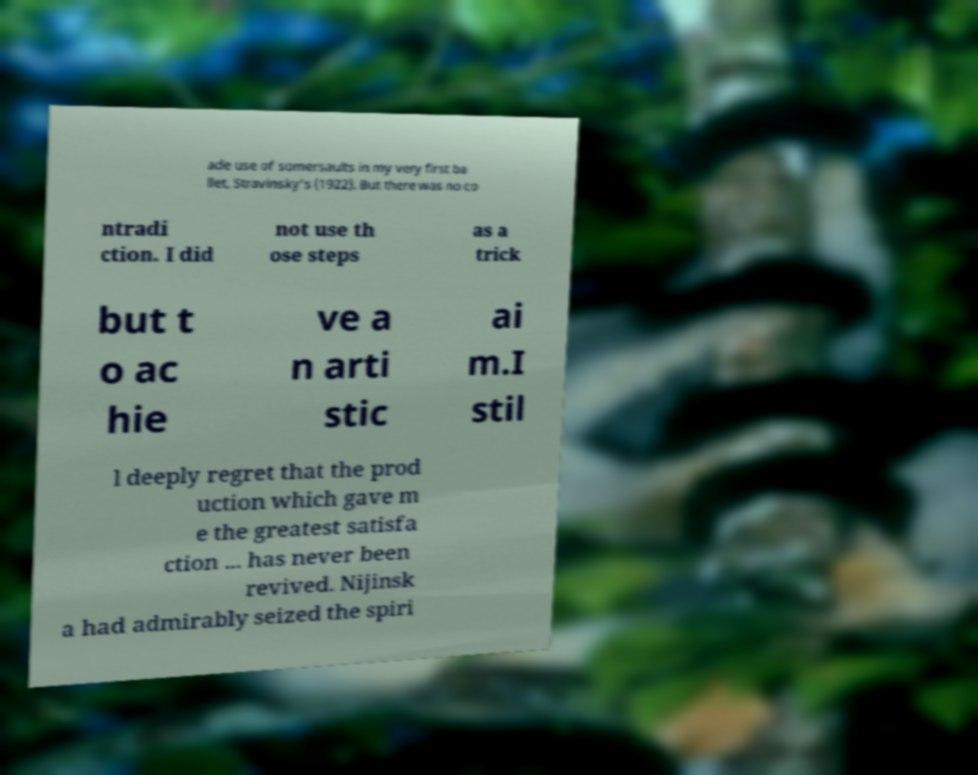There's text embedded in this image that I need extracted. Can you transcribe it verbatim? ade use of somersaults in my very first ba llet, Stravinsky's (1922). But there was no co ntradi ction. I did not use th ose steps as a trick but t o ac hie ve a n arti stic ai m.I stil l deeply regret that the prod uction which gave m e the greatest satisfa ction ... has never been revived. Nijinsk a had admirably seized the spiri 